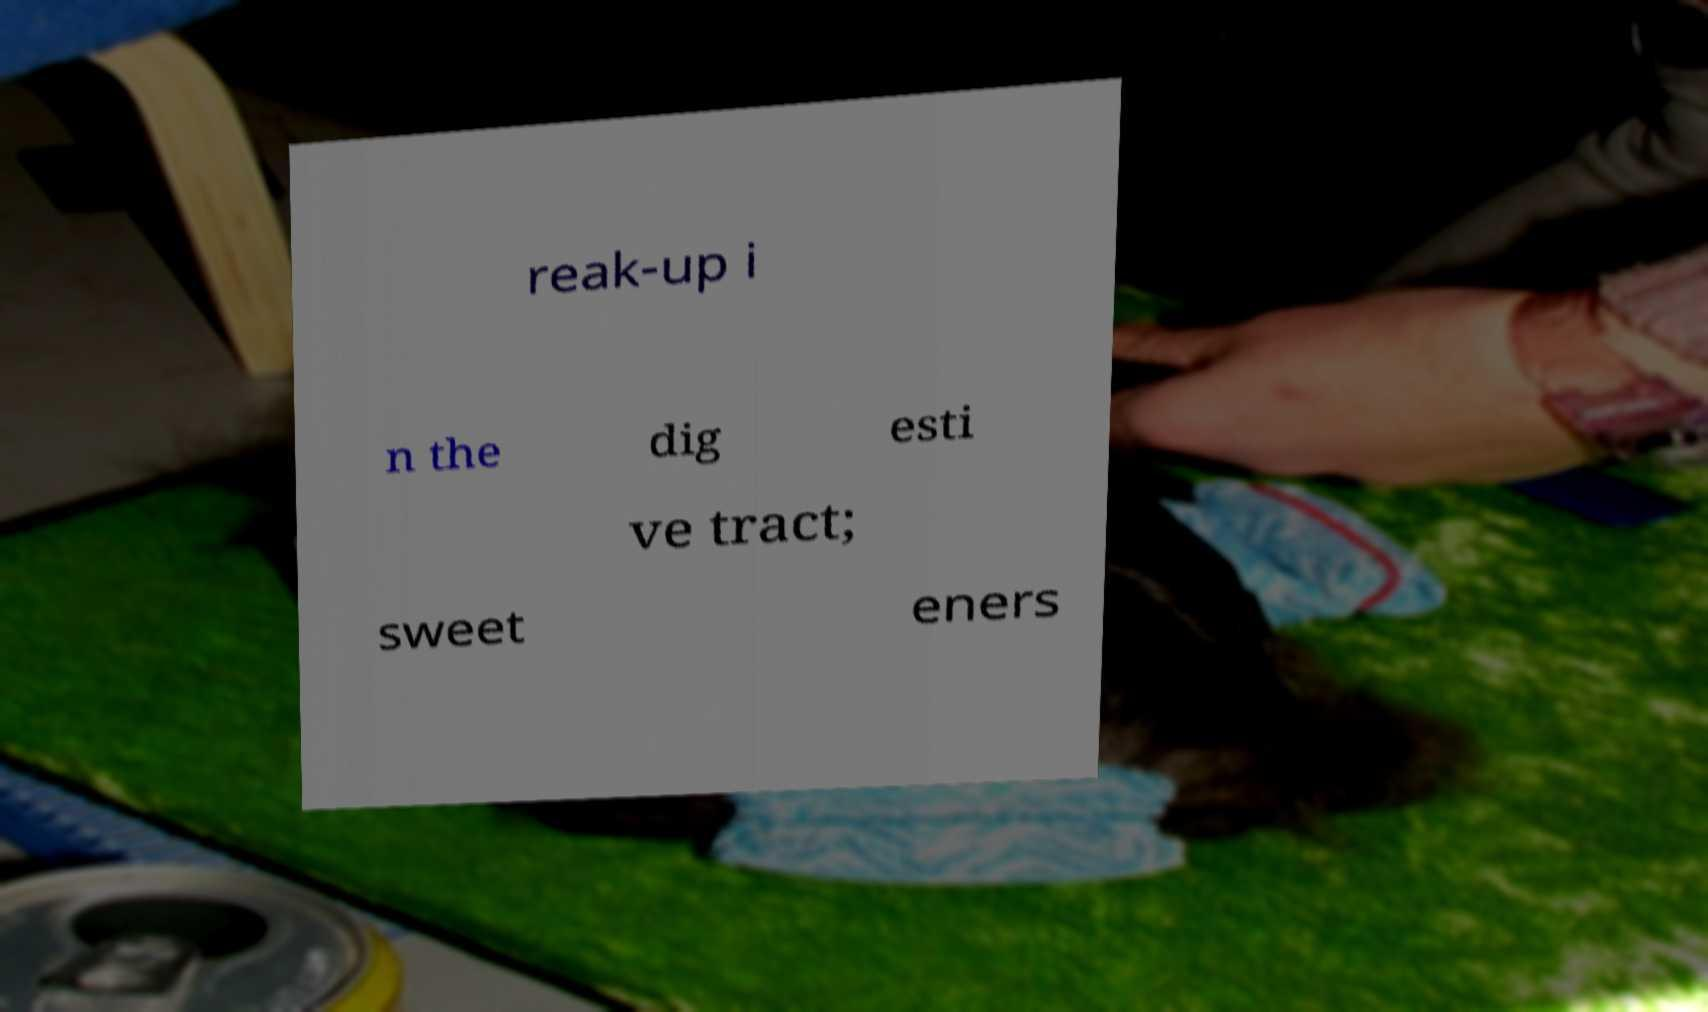I need the written content from this picture converted into text. Can you do that? reak-up i n the dig esti ve tract; sweet eners 